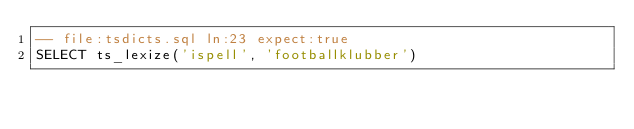<code> <loc_0><loc_0><loc_500><loc_500><_SQL_>-- file:tsdicts.sql ln:23 expect:true
SELECT ts_lexize('ispell', 'footballklubber')
</code> 